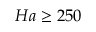<formula> <loc_0><loc_0><loc_500><loc_500>H a \geq 2 5 0</formula> 